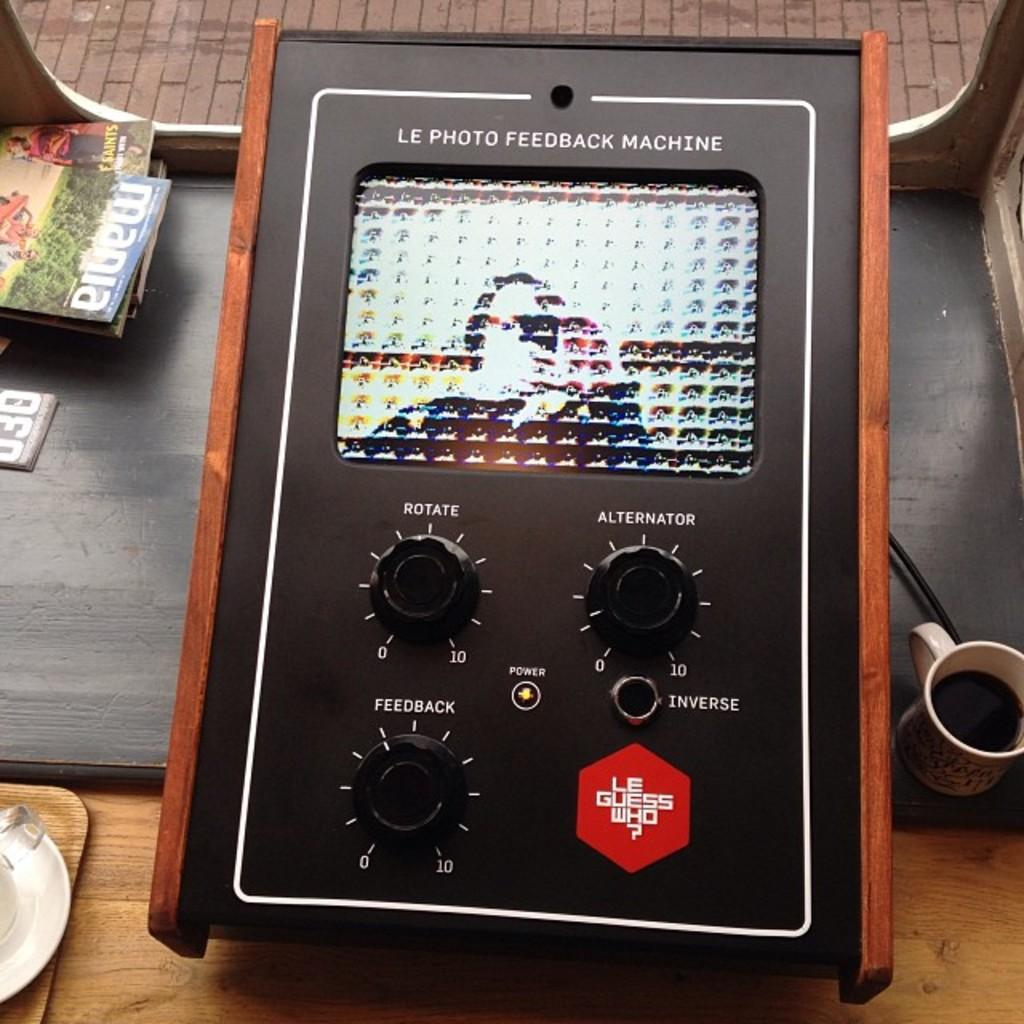<image>
Relay a brief, clear account of the picture shown. A Le Photo Feedback Machine sitting on a table 